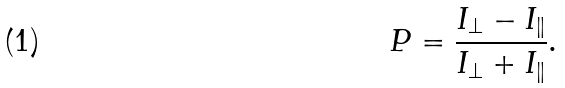<formula> <loc_0><loc_0><loc_500><loc_500>P = \frac { I _ { \perp } - I _ { \| } } { I _ { \perp } + I _ { \| } } .</formula> 